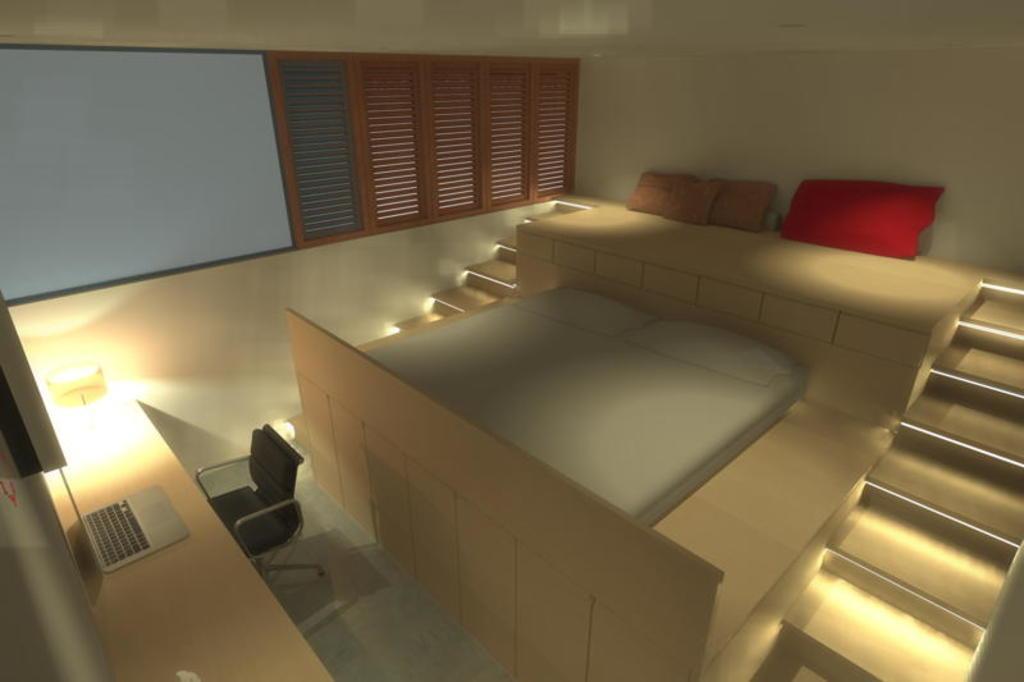How would you summarize this image in a sentence or two? In the picture there is a beautiful interior, there is a bed, stairs, chair, a laptop, windows and a lamp in the image. 